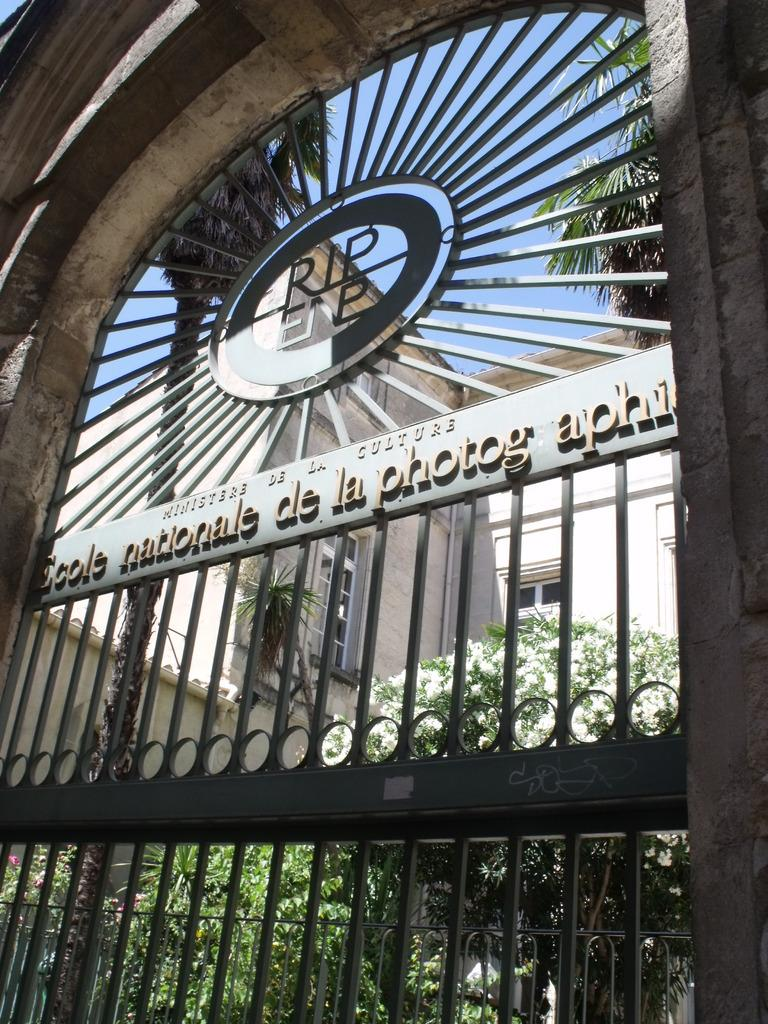What structure with a railing can be seen in the image? There is an arch with a railing in the image. What is written on the arch? Something is written on the arch. What decorative element is present in the image? There is an emblem in the image. What can be seen through the arch? Trees and a building are visible through the arch. What part of the natural environment is visible in the image? The sky is visible in the image. What type of sock is the mother wearing in the image? There is no mother or sock present in the image. How is the string used in the image? There is no string present in the image. 